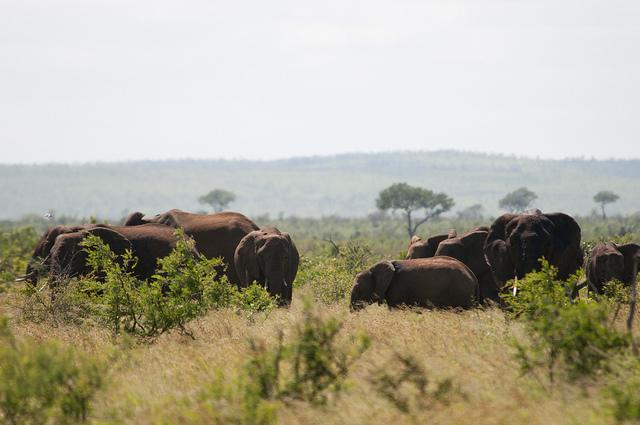What are this elephants doing?
Write a very short answer. Walking. Is this a herd?
Short answer required. Yes. What do you think this scene is portraying?
Quick response, please. Wild. What color is the ground covering?
Answer briefly. Brown. Are the elephants in their natural habitat?
Write a very short answer. Yes. Do you see the bird?
Write a very short answer. No. 